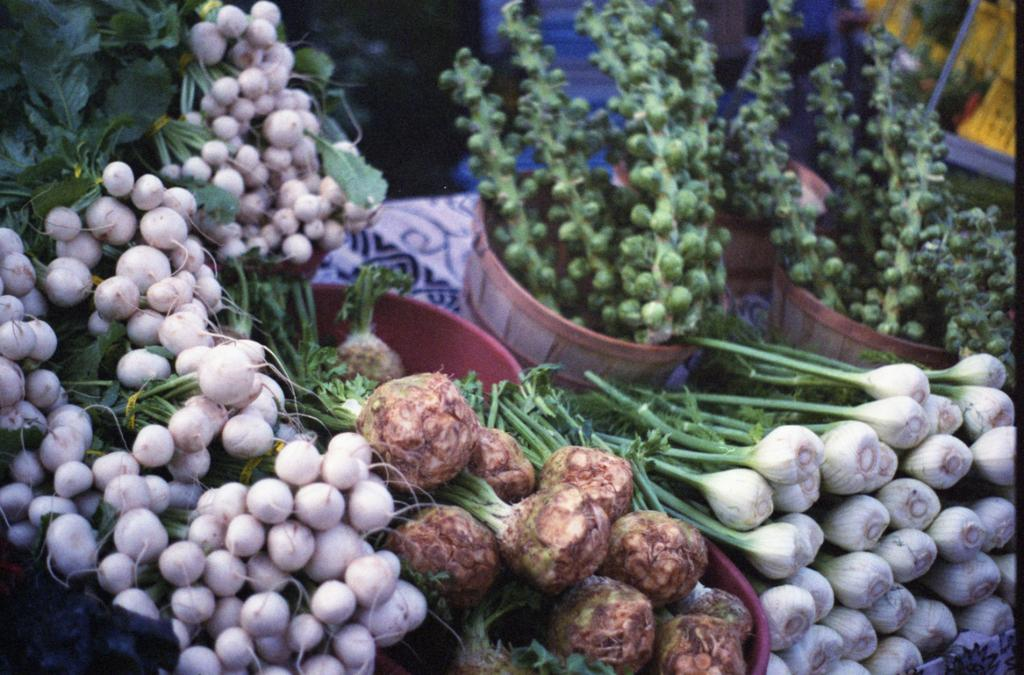What type of food items are present in the image? There are vegetables in the image. How are the vegetables arranged or stored in the image? The vegetables are in baskets. What time does the clock in the image show? There is no clock present in the image. 